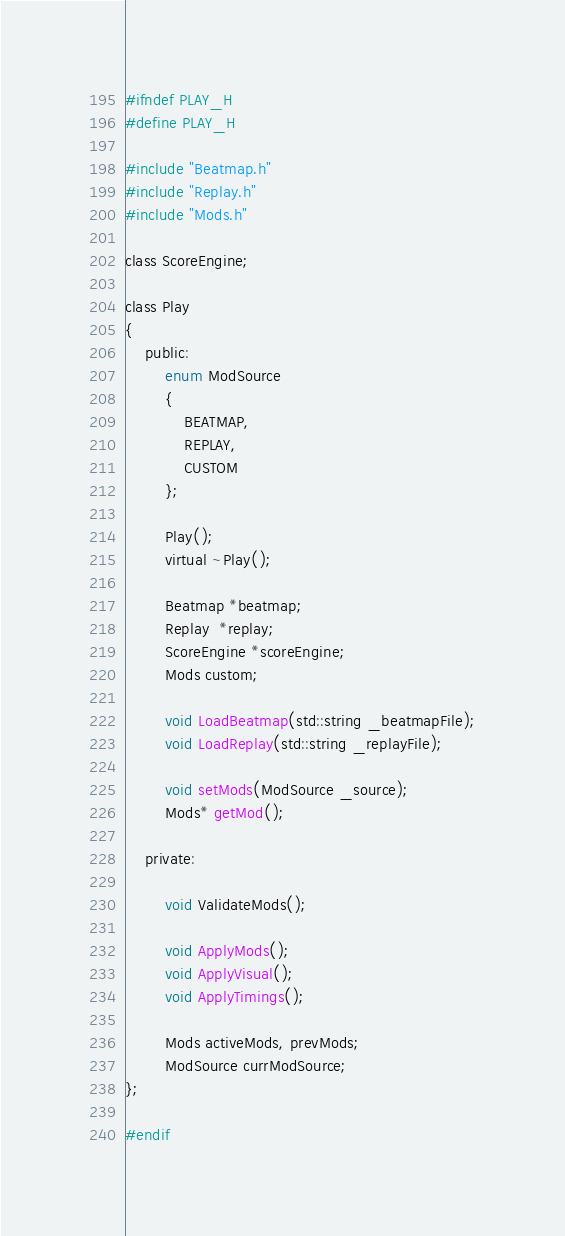Convert code to text. <code><loc_0><loc_0><loc_500><loc_500><_C_>#ifndef PLAY_H
#define PLAY_H

#include "Beatmap.h"
#include "Replay.h"
#include "Mods.h"

class ScoreEngine;

class Play
{
	public:
		enum ModSource
		{
			BEATMAP,
			REPLAY,
			CUSTOM
		};

		Play();
		virtual ~Play();

		Beatmap *beatmap;
		Replay  *replay;
		ScoreEngine *scoreEngine;
		Mods custom;

		void LoadBeatmap(std::string _beatmapFile);
		void LoadReplay(std::string _replayFile);
		
		void setMods(ModSource _source);
		Mods* getMod();

	private:
		
		void ValidateMods();

		void ApplyMods();
		void ApplyVisual();
		void ApplyTimings();

		Mods activeMods, prevMods;
		ModSource currModSource;
};

#endif</code> 